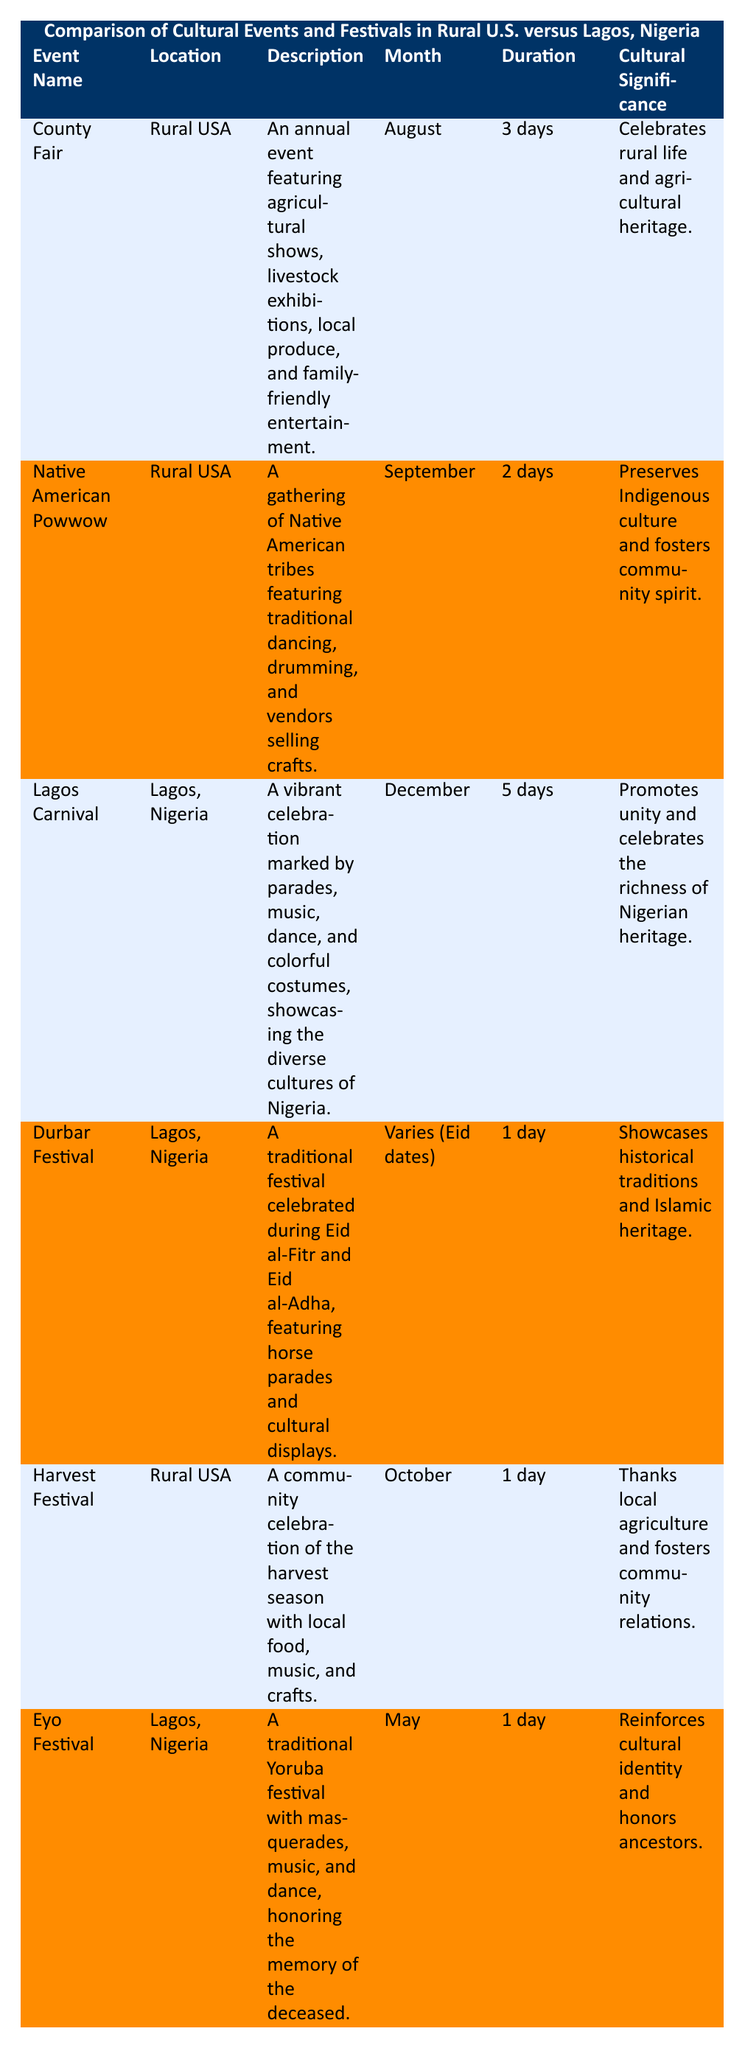What is the duration of the Lagos Carnival? The table lists the Lagos Carnival event and indicates its duration as "5 days."
Answer: 5 days In which month does the County Fair occur? The table specifies the County Fair event and mentions that it takes place in "August."
Answer: August How many participants are involved in the Eyo Festival? The table shows that the Eyo Festival involves "Masqueraders, local leaders, community members," which indicates multiple participants, but does not specify a number. Thus, it is qualitative rather than quantitative.
Answer: Not specified What is the cultural significance of the Native American Powwow? The table notes that the significance of the Native American Powwow is to "preserve Indigenous culture and foster community spirit."
Answer: Preserves Indigenous culture and fosters community spirit Which festival has the longest duration? The Lagos Carnival lasts "5 days," which is longer than any other event in the table, all of which are either shorter in duration or just one day long.
Answer: Lagos Carnival How many cultural events are held in rural USA? The table lists three events specifically located in rural USA: County Fair, Native American Powwow, and Harvest Festival, thus there are three.
Answer: 3 Is the Harvest Festival held in June? The table states that the Harvest Festival occurs in "October," confirming it is not in June.
Answer: No What is the total number of days for cultural events in rural USA? The events in rural USA last for: 3 days (County Fair) + 2 days (Native American Powwow) + 1 day (Harvest Festival) = 6 days total.
Answer: 6 days During which month does the Durbar Festival occur? The table specifies that the Durbar Festival's timing "Varies (Eid dates)," meaning it does not have a fixed month.
Answer: Varies (Eid dates) Which event in Lagos, Nigeria, is specifically honoring ancestors? The Eyo Festival is described in the table as a festival "honoring the memory of the deceased."
Answer: Eyo Festival Which rural USA event has the fewest participants mentioned? Among the events listed, the Harvest Festival has the participant group listed as "local farmers, families, artisans," which is the least specific as it does not denote a variety of groups, hence can be assumed to be fewer than the others.
Answer: Harvest Festival 